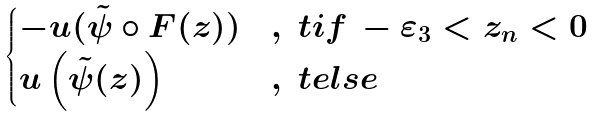<formula> <loc_0><loc_0><loc_500><loc_500>\begin{cases} - u ( \tilde { \psi } \circ F ( z ) ) & , \ t i f \, - \varepsilon _ { 3 } < z _ { n } < 0 \\ u \left ( \tilde { \psi } ( z ) \right ) & , \ t e l s e \end{cases}</formula> 